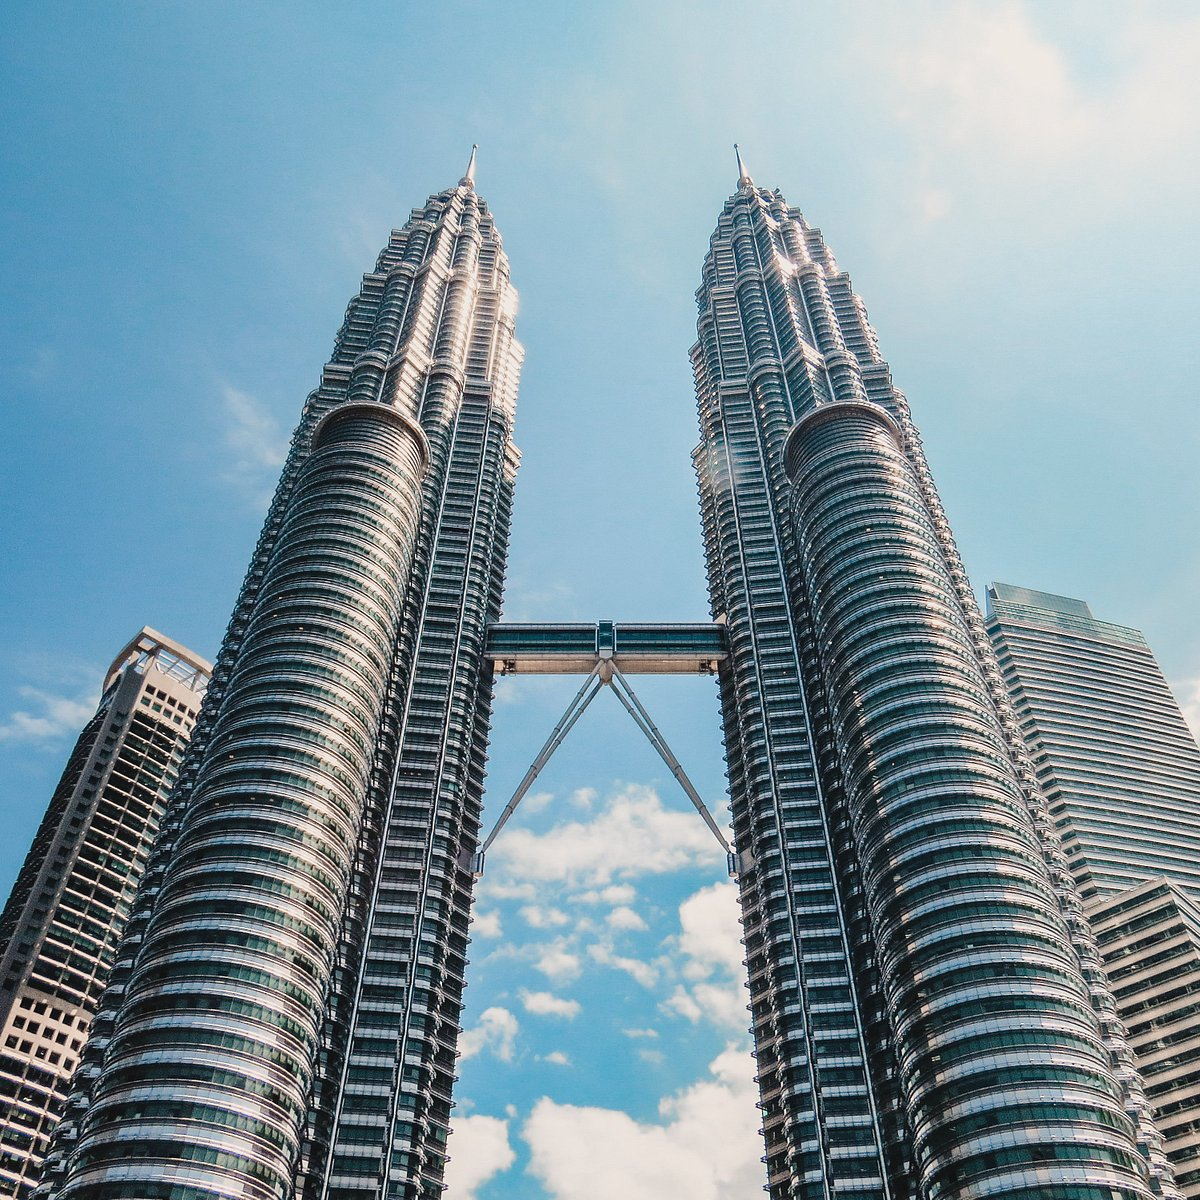What role does the skybridge play in the functionality of the Petronas Towers? The skybridge of the Petronas Twin Towers, which links the two towers at the 41st and 42nd floors, plays a crucial role not only in terms of aesthetics but also in practical functionality. It serves as a vital escape route in emergency situations, allowing for the evacuation of people from one tower to the other. Additionally, it functions as a public viewing deck, providing visitors with a panoramic view of Kuala Lumpur while also stabilizing the towers against wind forces. 